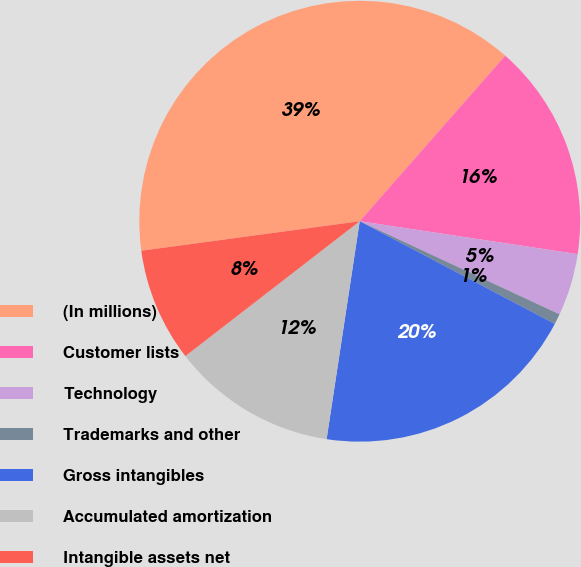<chart> <loc_0><loc_0><loc_500><loc_500><pie_chart><fcel>(In millions)<fcel>Customer lists<fcel>Technology<fcel>Trademarks and other<fcel>Gross intangibles<fcel>Accumulated amortization<fcel>Intangible assets net<nl><fcel>38.61%<fcel>15.91%<fcel>4.55%<fcel>0.77%<fcel>19.69%<fcel>12.12%<fcel>8.34%<nl></chart> 